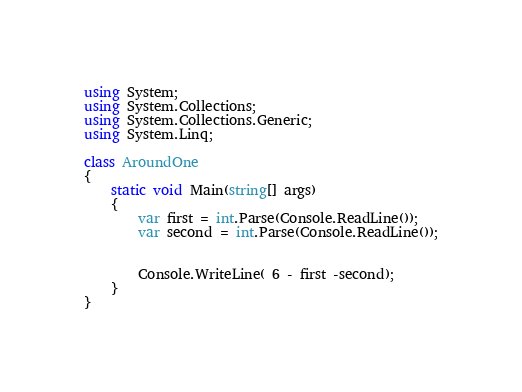<code> <loc_0><loc_0><loc_500><loc_500><_C#_>using System;
using System.Collections;
using System.Collections.Generic;
using System.Linq;

class AroundOne
{
    static void Main(string[] args)
    {
        var first = int.Parse(Console.ReadLine());
        var second = int.Parse(Console.ReadLine());


        Console.WriteLine( 6 - first -second);
    }
}</code> 